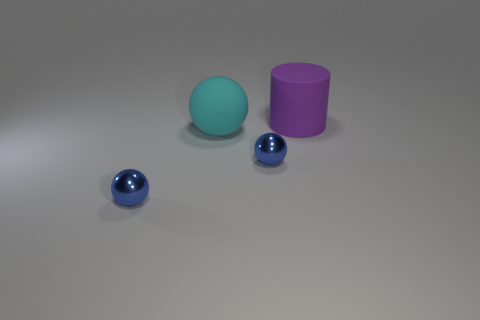Is there anything else that is the same size as the purple matte cylinder?
Ensure brevity in your answer.  Yes. Is the number of metal balls that are behind the rubber ball less than the number of large purple things?
Offer a very short reply. Yes. Is the big purple rubber object the same shape as the big cyan matte thing?
Provide a short and direct response. No. How many big spheres have the same color as the cylinder?
Give a very brief answer. 0. How many objects are small metallic things to the right of the large sphere or small blue balls?
Offer a very short reply. 2. How big is the rubber object that is to the left of the big purple matte object?
Make the answer very short. Large. Is the number of large cyan objects less than the number of blue metal objects?
Your response must be concise. Yes. Does the thing that is to the left of the big cyan matte thing have the same material as the big object behind the cyan rubber sphere?
Keep it short and to the point. No. The small thing right of the blue sphere left of the big rubber object that is to the left of the big matte cylinder is what shape?
Give a very brief answer. Sphere. What number of purple objects have the same material as the large cyan sphere?
Your answer should be very brief. 1. 